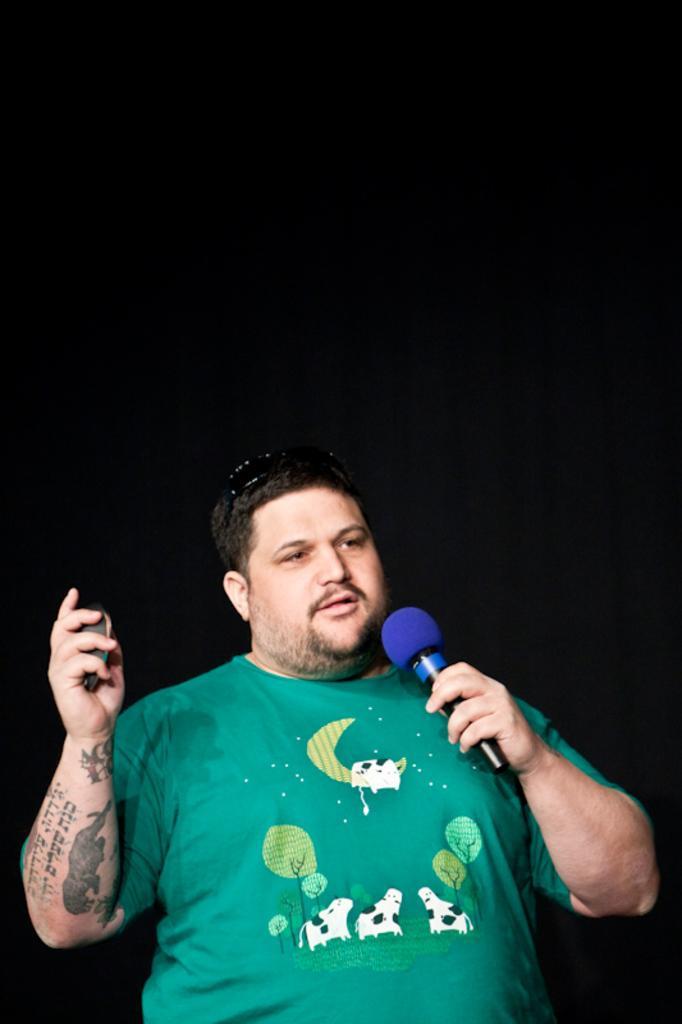Describe this image in one or two sentences. In this image, man in green t-shirt. He hold microphone on his hand and some item. He is talking, he wear a tattoo on his hand. 